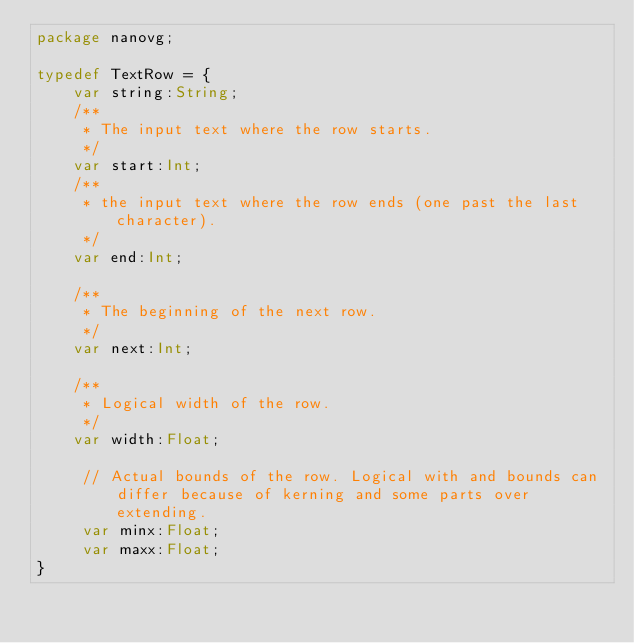<code> <loc_0><loc_0><loc_500><loc_500><_Haxe_>package nanovg;

typedef TextRow = {
    var string:String;
    /**
     * The input text where the row starts.
     */
    var start:Int;
    /**
     * the input text where the row ends (one past the last character).
     */
    var end:Int;

    /**
     * The beginning of the next row.
     */
    var next:Int;

    /**
     * Logical width of the row.
     */
    var width:Float;

     // Actual bounds of the row. Logical with and bounds can differ because of kerning and some parts over extending.
     var minx:Float;
     var maxx:Float;
}</code> 